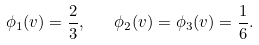Convert formula to latex. <formula><loc_0><loc_0><loc_500><loc_500>\phi _ { 1 } ( v ) = \frac { 2 } { 3 } , \quad \phi _ { 2 } ( v ) = \phi _ { 3 } ( v ) = \frac { 1 } { 6 } .</formula> 